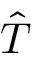<formula> <loc_0><loc_0><loc_500><loc_500>\hat { T }</formula> 